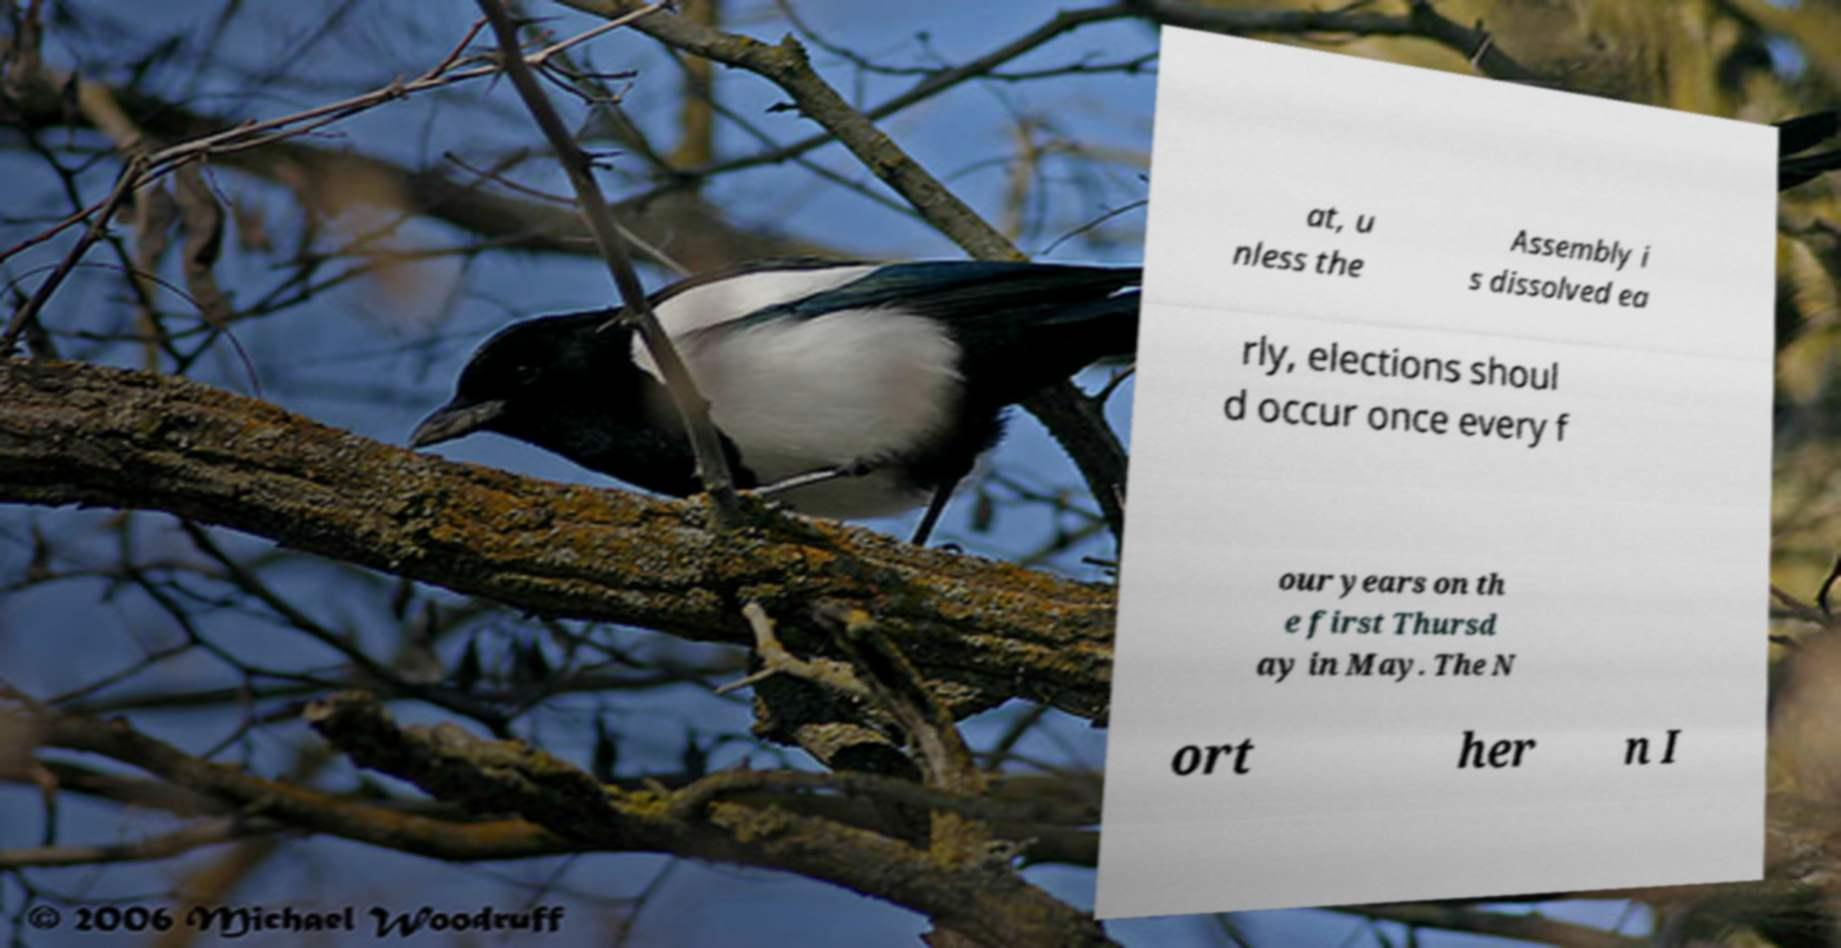Could you extract and type out the text from this image? at, u nless the Assembly i s dissolved ea rly, elections shoul d occur once every f our years on th e first Thursd ay in May. The N ort her n I 